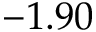Convert formula to latex. <formula><loc_0><loc_0><loc_500><loc_500>- 1 . 9 0</formula> 